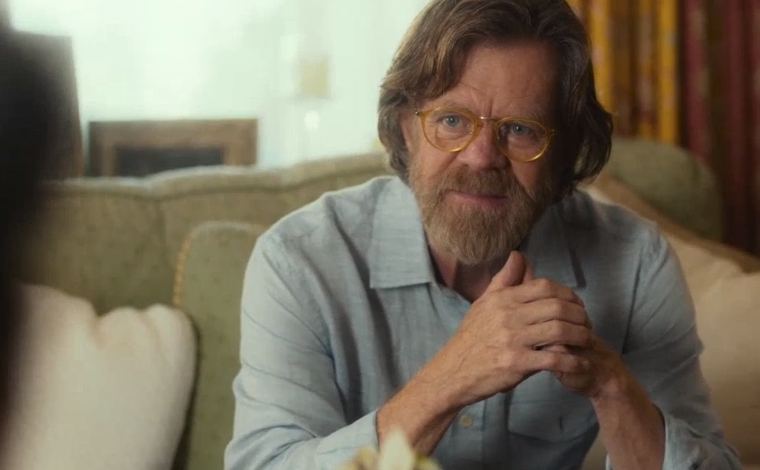Explain the visual content of the image in great detail.
 In this image, the renowned actor William H. Macy is captured in a moment of quiet contemplation. Seated comfortably on a green armchair in a cozy living room setting, he is dressed casually in a blue shirt. His beard and glasses add an air of intellectual curiosity to his persona. His hands are clasped together, perhaps indicating deep thought or concern. He is looking off-screen, his gaze fixed on someone or something not visible in the frame, and his expression is one of concern. The room around him is warmly lit, with a fireplace and a window adorned with yellow curtains in the background, adding to the intimate atmosphere of the scene. 